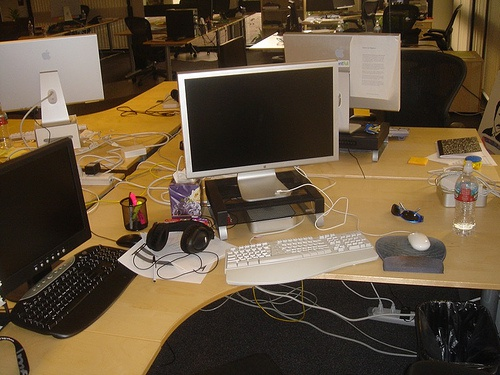Describe the objects in this image and their specific colors. I can see tv in black, lightgray, darkgray, and gray tones, tv in black, maroon, and gray tones, keyboard in black and gray tones, keyboard in black, darkgray, lightgray, and tan tones, and chair in black, maroon, olive, and gray tones in this image. 